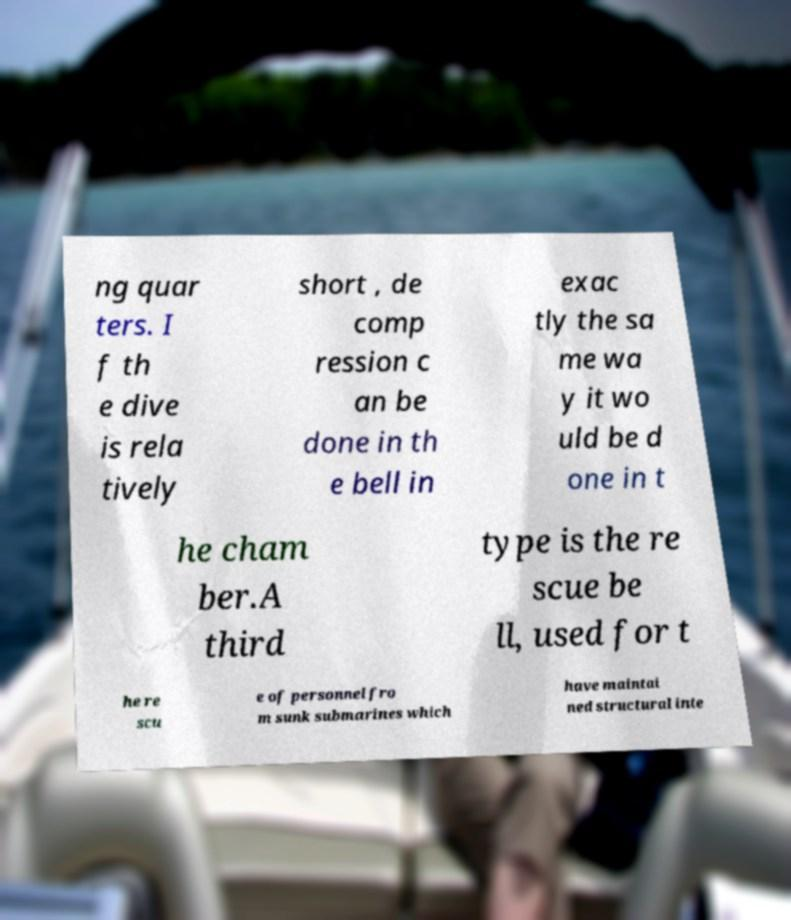For documentation purposes, I need the text within this image transcribed. Could you provide that? ng quar ters. I f th e dive is rela tively short , de comp ression c an be done in th e bell in exac tly the sa me wa y it wo uld be d one in t he cham ber.A third type is the re scue be ll, used for t he re scu e of personnel fro m sunk submarines which have maintai ned structural inte 